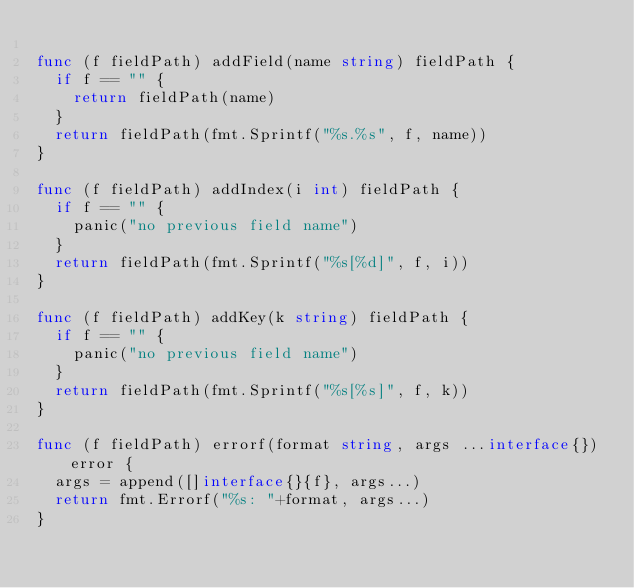<code> <loc_0><loc_0><loc_500><loc_500><_Go_>
func (f fieldPath) addField(name string) fieldPath {
	if f == "" {
		return fieldPath(name)
	}
	return fieldPath(fmt.Sprintf("%s.%s", f, name))
}

func (f fieldPath) addIndex(i int) fieldPath {
	if f == "" {
		panic("no previous field name")
	}
	return fieldPath(fmt.Sprintf("%s[%d]", f, i))
}

func (f fieldPath) addKey(k string) fieldPath {
	if f == "" {
		panic("no previous field name")
	}
	return fieldPath(fmt.Sprintf("%s[%s]", f, k))
}

func (f fieldPath) errorf(format string, args ...interface{}) error {
	args = append([]interface{}{f}, args...)
	return fmt.Errorf("%s: "+format, args...)
}
</code> 